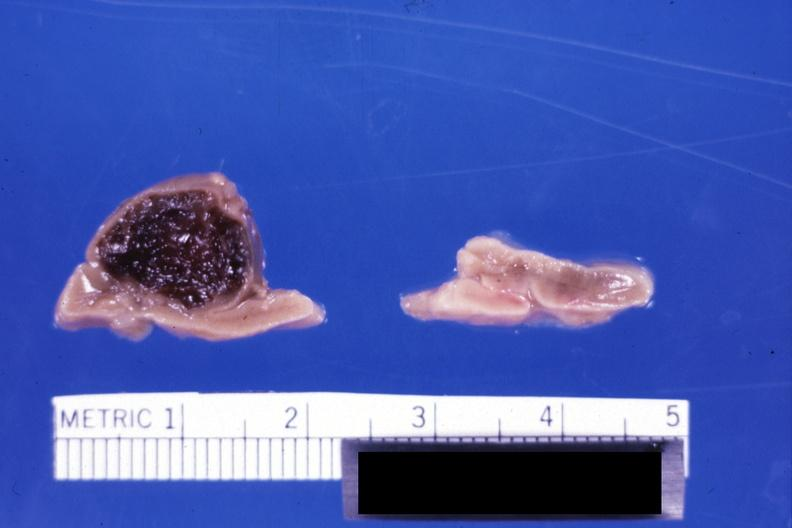what is present?
Answer the question using a single word or phrase. Hematoma 